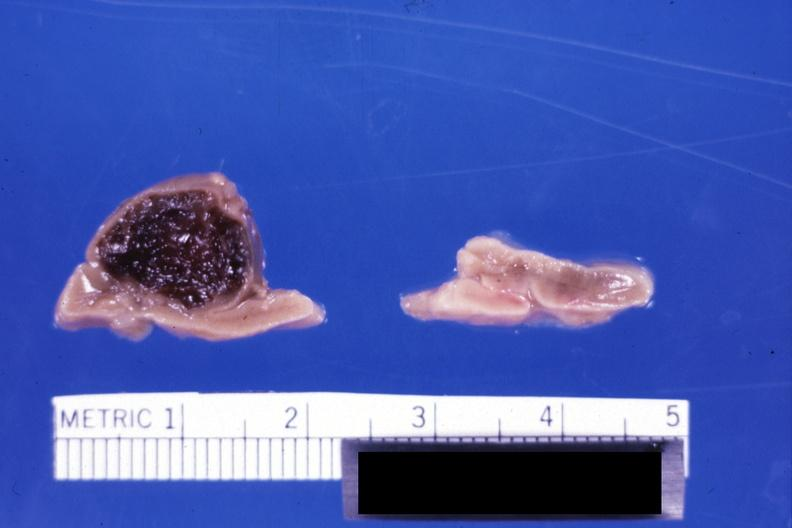what is present?
Answer the question using a single word or phrase. Hematoma 